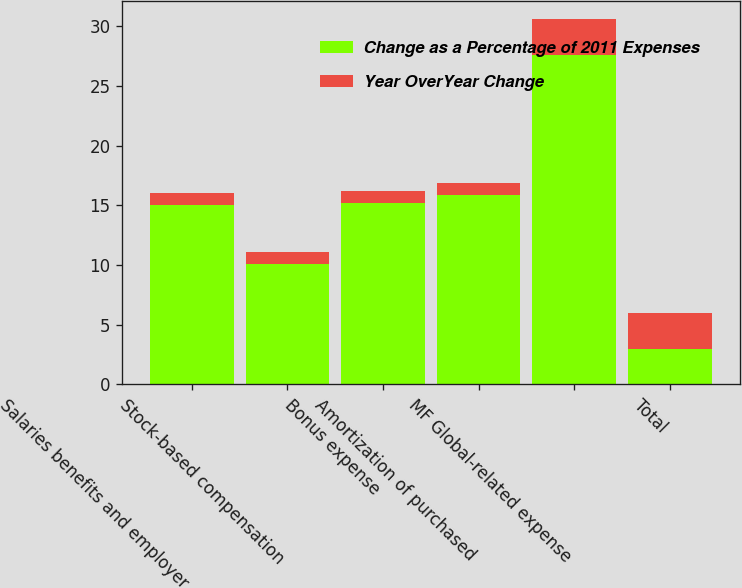Convert chart. <chart><loc_0><loc_0><loc_500><loc_500><stacked_bar_chart><ecel><fcel>Salaries benefits and employer<fcel>Stock-based compensation<fcel>Bonus expense<fcel>Amortization of purchased<fcel>MF Global-related expense<fcel>Total<nl><fcel>Change as a Percentage of 2011 Expenses<fcel>15<fcel>10.1<fcel>15.2<fcel>15.9<fcel>27.6<fcel>3<nl><fcel>Year OverYear Change<fcel>1<fcel>1<fcel>1<fcel>1<fcel>3<fcel>3<nl></chart> 